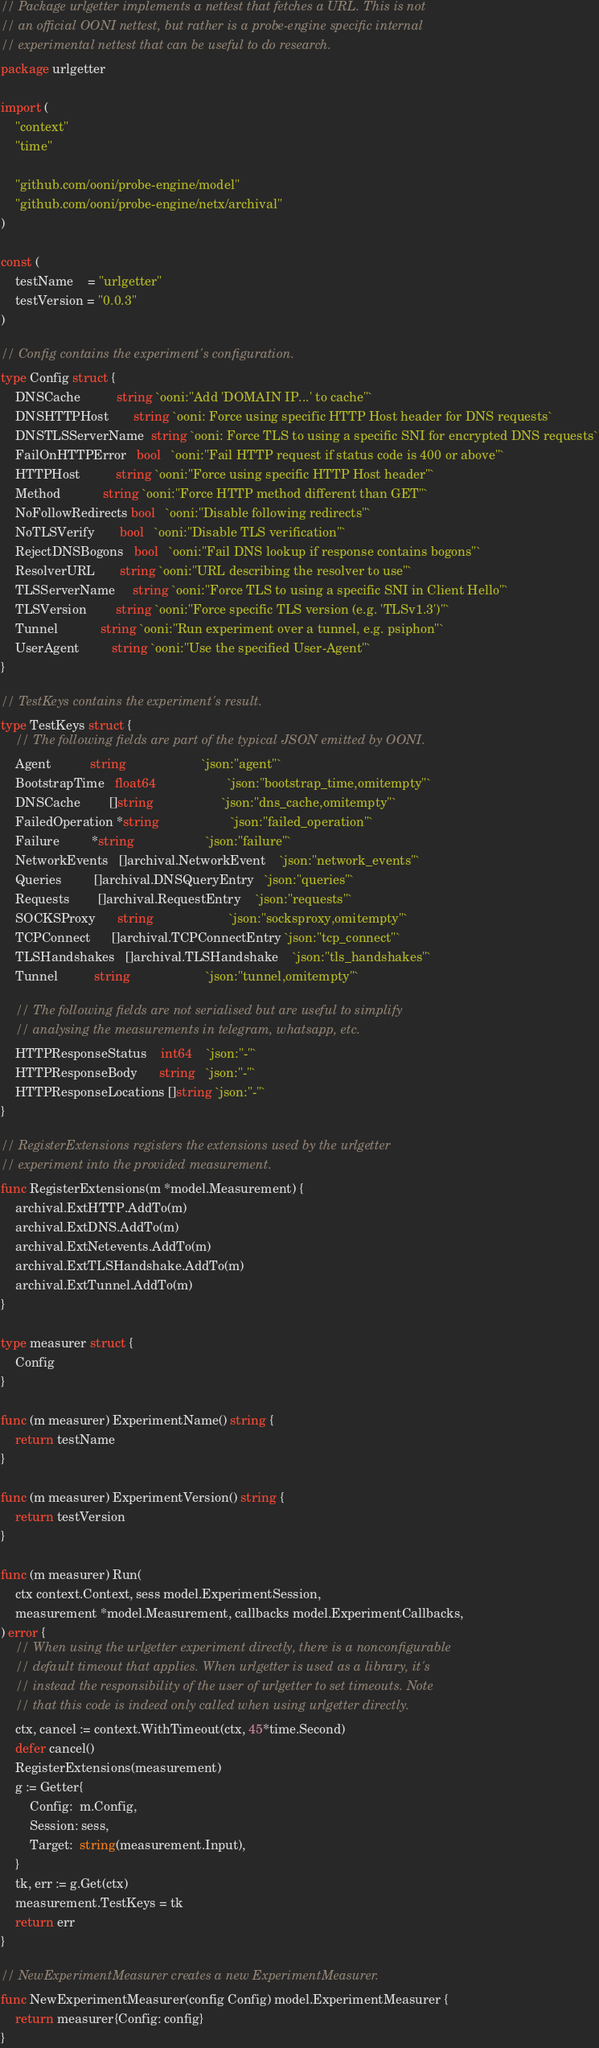Convert code to text. <code><loc_0><loc_0><loc_500><loc_500><_Go_>// Package urlgetter implements a nettest that fetches a URL. This is not
// an official OONI nettest, but rather is a probe-engine specific internal
// experimental nettest that can be useful to do research.
package urlgetter

import (
	"context"
	"time"

	"github.com/ooni/probe-engine/model"
	"github.com/ooni/probe-engine/netx/archival"
)

const (
	testName    = "urlgetter"
	testVersion = "0.0.3"
)

// Config contains the experiment's configuration.
type Config struct {
	DNSCache          string `ooni:"Add 'DOMAIN IP...' to cache"`
	DNSHTTPHost       string `ooni: Force using specific HTTP Host header for DNS requests`
	DNSTLSServerName  string `ooni: Force TLS to using a specific SNI for encrypted DNS requests`
	FailOnHTTPError   bool   `ooni:"Fail HTTP request if status code is 400 or above"`
	HTTPHost          string `ooni:"Force using specific HTTP Host header"`
	Method            string `ooni:"Force HTTP method different than GET"`
	NoFollowRedirects bool   `ooni:"Disable following redirects"`
	NoTLSVerify       bool   `ooni:"Disable TLS verification"`
	RejectDNSBogons   bool   `ooni:"Fail DNS lookup if response contains bogons"`
	ResolverURL       string `ooni:"URL describing the resolver to use"`
	TLSServerName     string `ooni:"Force TLS to using a specific SNI in Client Hello"`
	TLSVersion        string `ooni:"Force specific TLS version (e.g. 'TLSv1.3')"`
	Tunnel            string `ooni:"Run experiment over a tunnel, e.g. psiphon"`
	UserAgent         string `ooni:"Use the specified User-Agent"`
}

// TestKeys contains the experiment's result.
type TestKeys struct {
	// The following fields are part of the typical JSON emitted by OONI.
	Agent           string                     `json:"agent"`
	BootstrapTime   float64                    `json:"bootstrap_time,omitempty"`
	DNSCache        []string                   `json:"dns_cache,omitempty"`
	FailedOperation *string                    `json:"failed_operation"`
	Failure         *string                    `json:"failure"`
	NetworkEvents   []archival.NetworkEvent    `json:"network_events"`
	Queries         []archival.DNSQueryEntry   `json:"queries"`
	Requests        []archival.RequestEntry    `json:"requests"`
	SOCKSProxy      string                     `json:"socksproxy,omitempty"`
	TCPConnect      []archival.TCPConnectEntry `json:"tcp_connect"`
	TLSHandshakes   []archival.TLSHandshake    `json:"tls_handshakes"`
	Tunnel          string                     `json:"tunnel,omitempty"`

	// The following fields are not serialised but are useful to simplify
	// analysing the measurements in telegram, whatsapp, etc.
	HTTPResponseStatus    int64    `json:"-"`
	HTTPResponseBody      string   `json:"-"`
	HTTPResponseLocations []string `json:"-"`
}

// RegisterExtensions registers the extensions used by the urlgetter
// experiment into the provided measurement.
func RegisterExtensions(m *model.Measurement) {
	archival.ExtHTTP.AddTo(m)
	archival.ExtDNS.AddTo(m)
	archival.ExtNetevents.AddTo(m)
	archival.ExtTLSHandshake.AddTo(m)
	archival.ExtTunnel.AddTo(m)
}

type measurer struct {
	Config
}

func (m measurer) ExperimentName() string {
	return testName
}

func (m measurer) ExperimentVersion() string {
	return testVersion
}

func (m measurer) Run(
	ctx context.Context, sess model.ExperimentSession,
	measurement *model.Measurement, callbacks model.ExperimentCallbacks,
) error {
	// When using the urlgetter experiment directly, there is a nonconfigurable
	// default timeout that applies. When urlgetter is used as a library, it's
	// instead the responsibility of the user of urlgetter to set timeouts. Note
	// that this code is indeed only called when using urlgetter directly.
	ctx, cancel := context.WithTimeout(ctx, 45*time.Second)
	defer cancel()
	RegisterExtensions(measurement)
	g := Getter{
		Config:  m.Config,
		Session: sess,
		Target:  string(measurement.Input),
	}
	tk, err := g.Get(ctx)
	measurement.TestKeys = tk
	return err
}

// NewExperimentMeasurer creates a new ExperimentMeasurer.
func NewExperimentMeasurer(config Config) model.ExperimentMeasurer {
	return measurer{Config: config}
}
</code> 